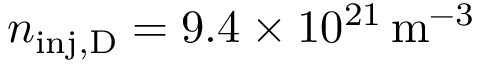Convert formula to latex. <formula><loc_0><loc_0><loc_500><loc_500>n _ { i n j , D } = 9 . 4 \times 1 0 ^ { 2 1 } \, m ^ { - 3 }</formula> 